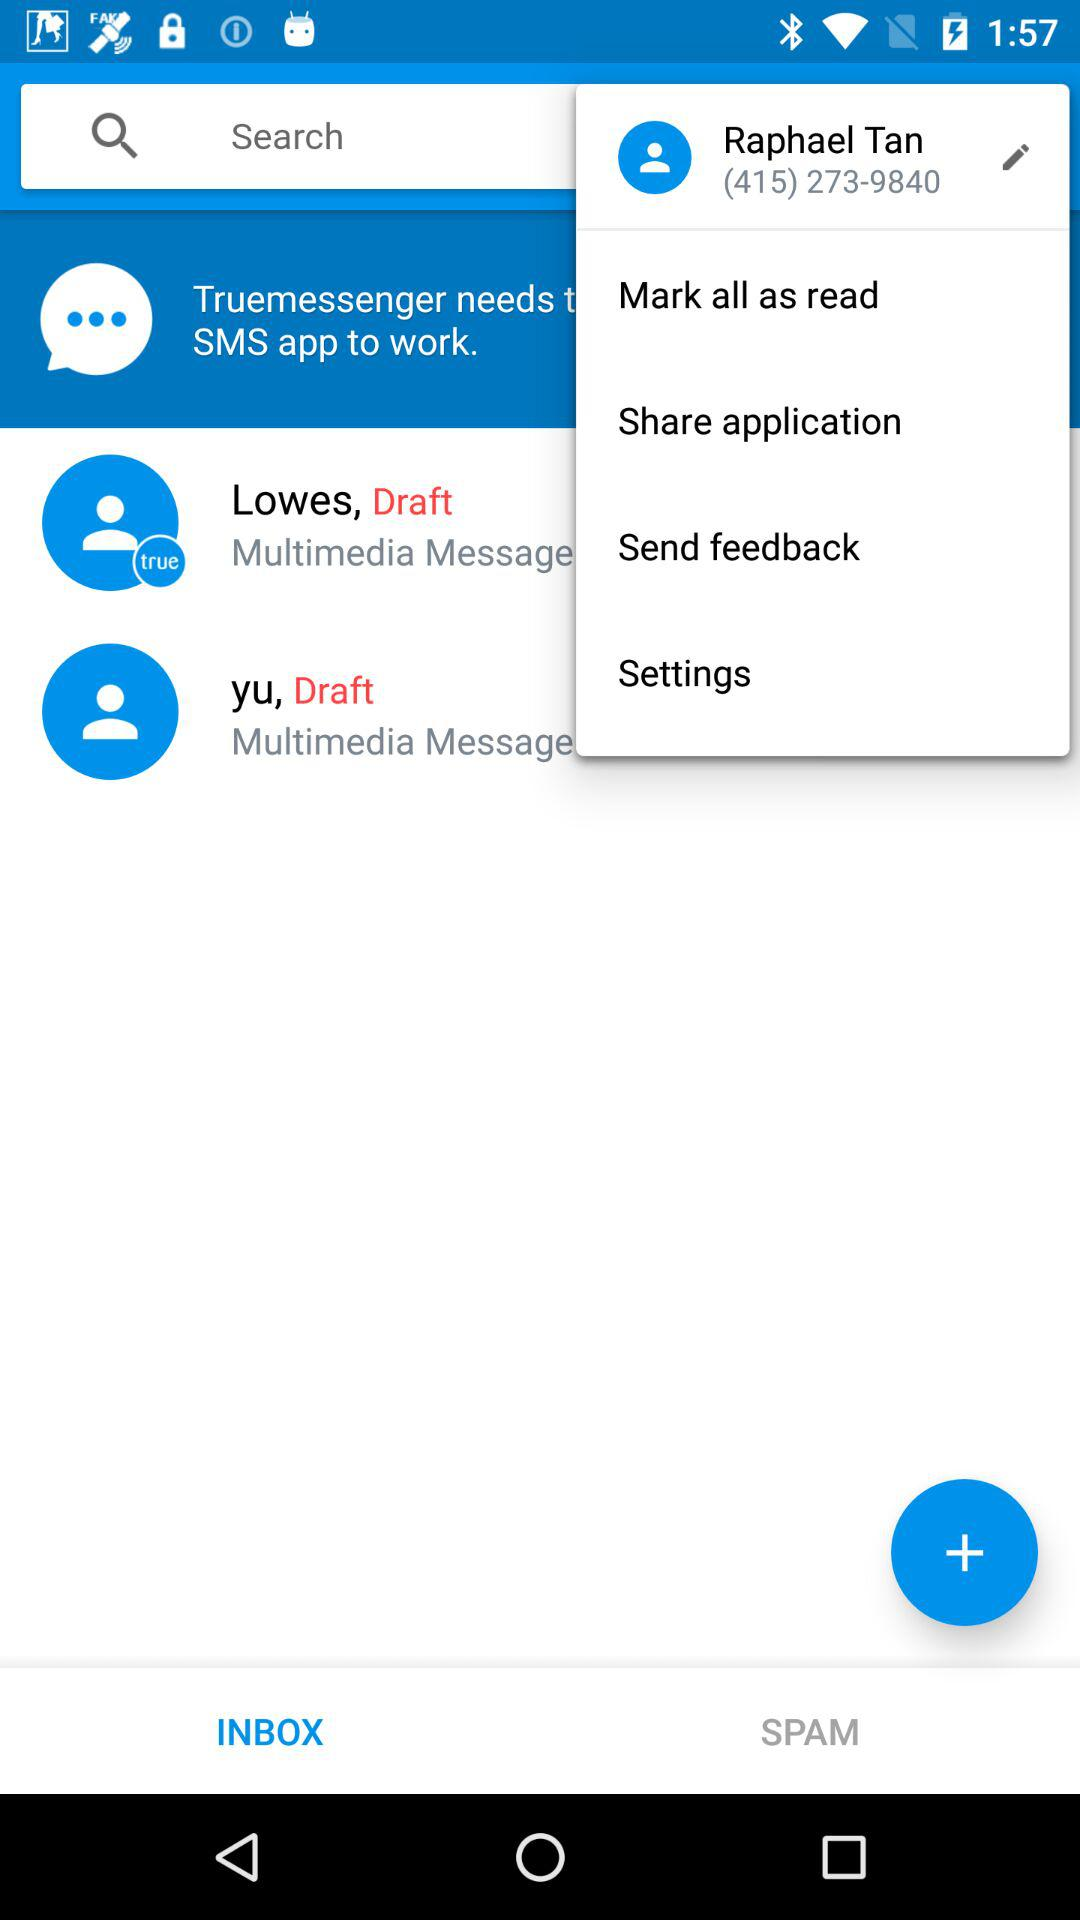What is the name of the user? The name of the user is "Raphael Tan". 